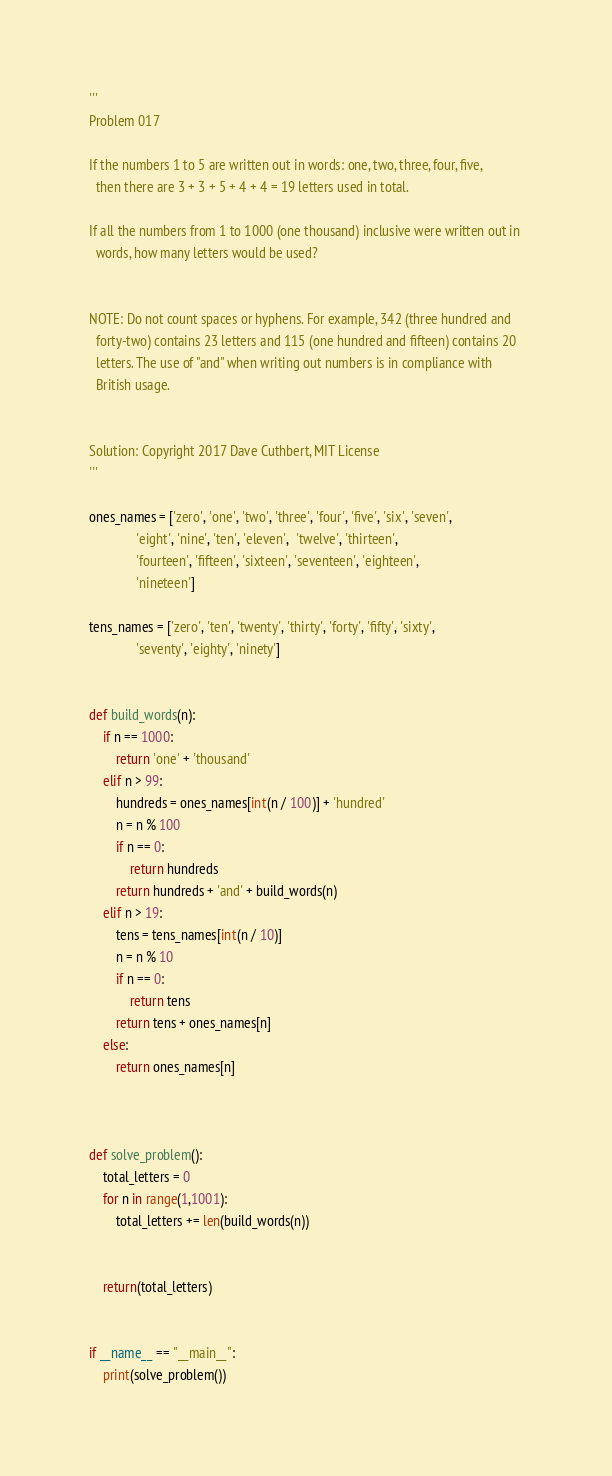Convert code to text. <code><loc_0><loc_0><loc_500><loc_500><_Python_>'''
Problem 017

If the numbers 1 to 5 are written out in words: one, two, three, four, five, 
  then there are 3 + 3 + 5 + 4 + 4 = 19 letters used in total.

If all the numbers from 1 to 1000 (one thousand) inclusive were written out in 
  words, how many letters would be used?


NOTE: Do not count spaces or hyphens. For example, 342 (three hundred and 
  forty-two) contains 23 letters and 115 (one hundred and fifteen) contains 20 
  letters. The use of "and" when writing out numbers is in compliance with 
  British usage. 


Solution: Copyright 2017 Dave Cuthbert, MIT License
'''

ones_names = ['zero', 'one', 'two', 'three', 'four', 'five', 'six', 'seven',
              'eight', 'nine', 'ten', 'eleven',  'twelve', 'thirteen',
              'fourteen', 'fifteen', 'sixteen', 'seventeen', 'eighteen',
              'nineteen']
              
tens_names = ['zero', 'ten', 'twenty', 'thirty', 'forty', 'fifty', 'sixty',
              'seventy', 'eighty', 'ninety']


def build_words(n):
    if n == 1000:
        return 'one' + 'thousand'
    elif n > 99:
        hundreds = ones_names[int(n / 100)] + 'hundred'
        n = n % 100
        if n == 0:
            return hundreds
        return hundreds + 'and' + build_words(n)
    elif n > 19:
        tens = tens_names[int(n / 10)]
        n = n % 10
        if n == 0:
            return tens
        return tens + ones_names[n]
    else:
        return ones_names[n]

    

def solve_problem():
    total_letters = 0
    for n in range(1,1001):
        total_letters += len(build_words(n))


    return(total_letters)


if __name__ == "__main__":
    print(solve_problem())
</code> 